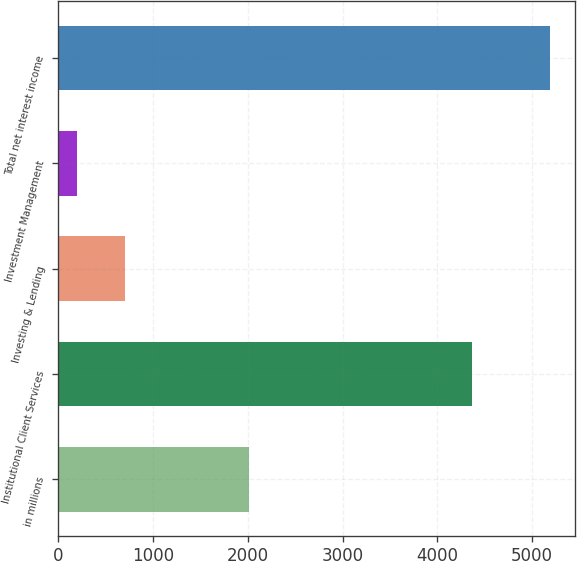Convert chart. <chart><loc_0><loc_0><loc_500><loc_500><bar_chart><fcel>in millions<fcel>Institutional Client Services<fcel>Investing & Lending<fcel>Investment Management<fcel>Total net interest income<nl><fcel>2011<fcel>4360<fcel>701.9<fcel>203<fcel>5192<nl></chart> 